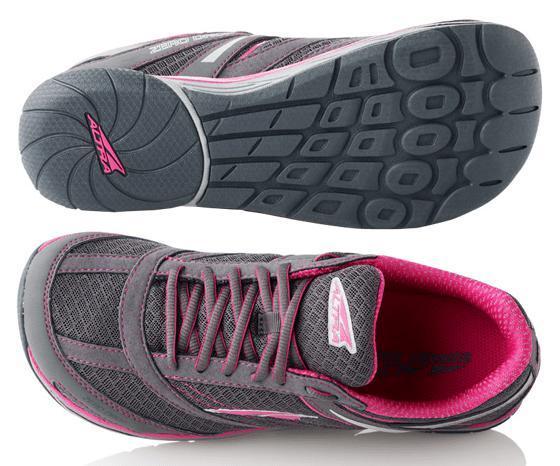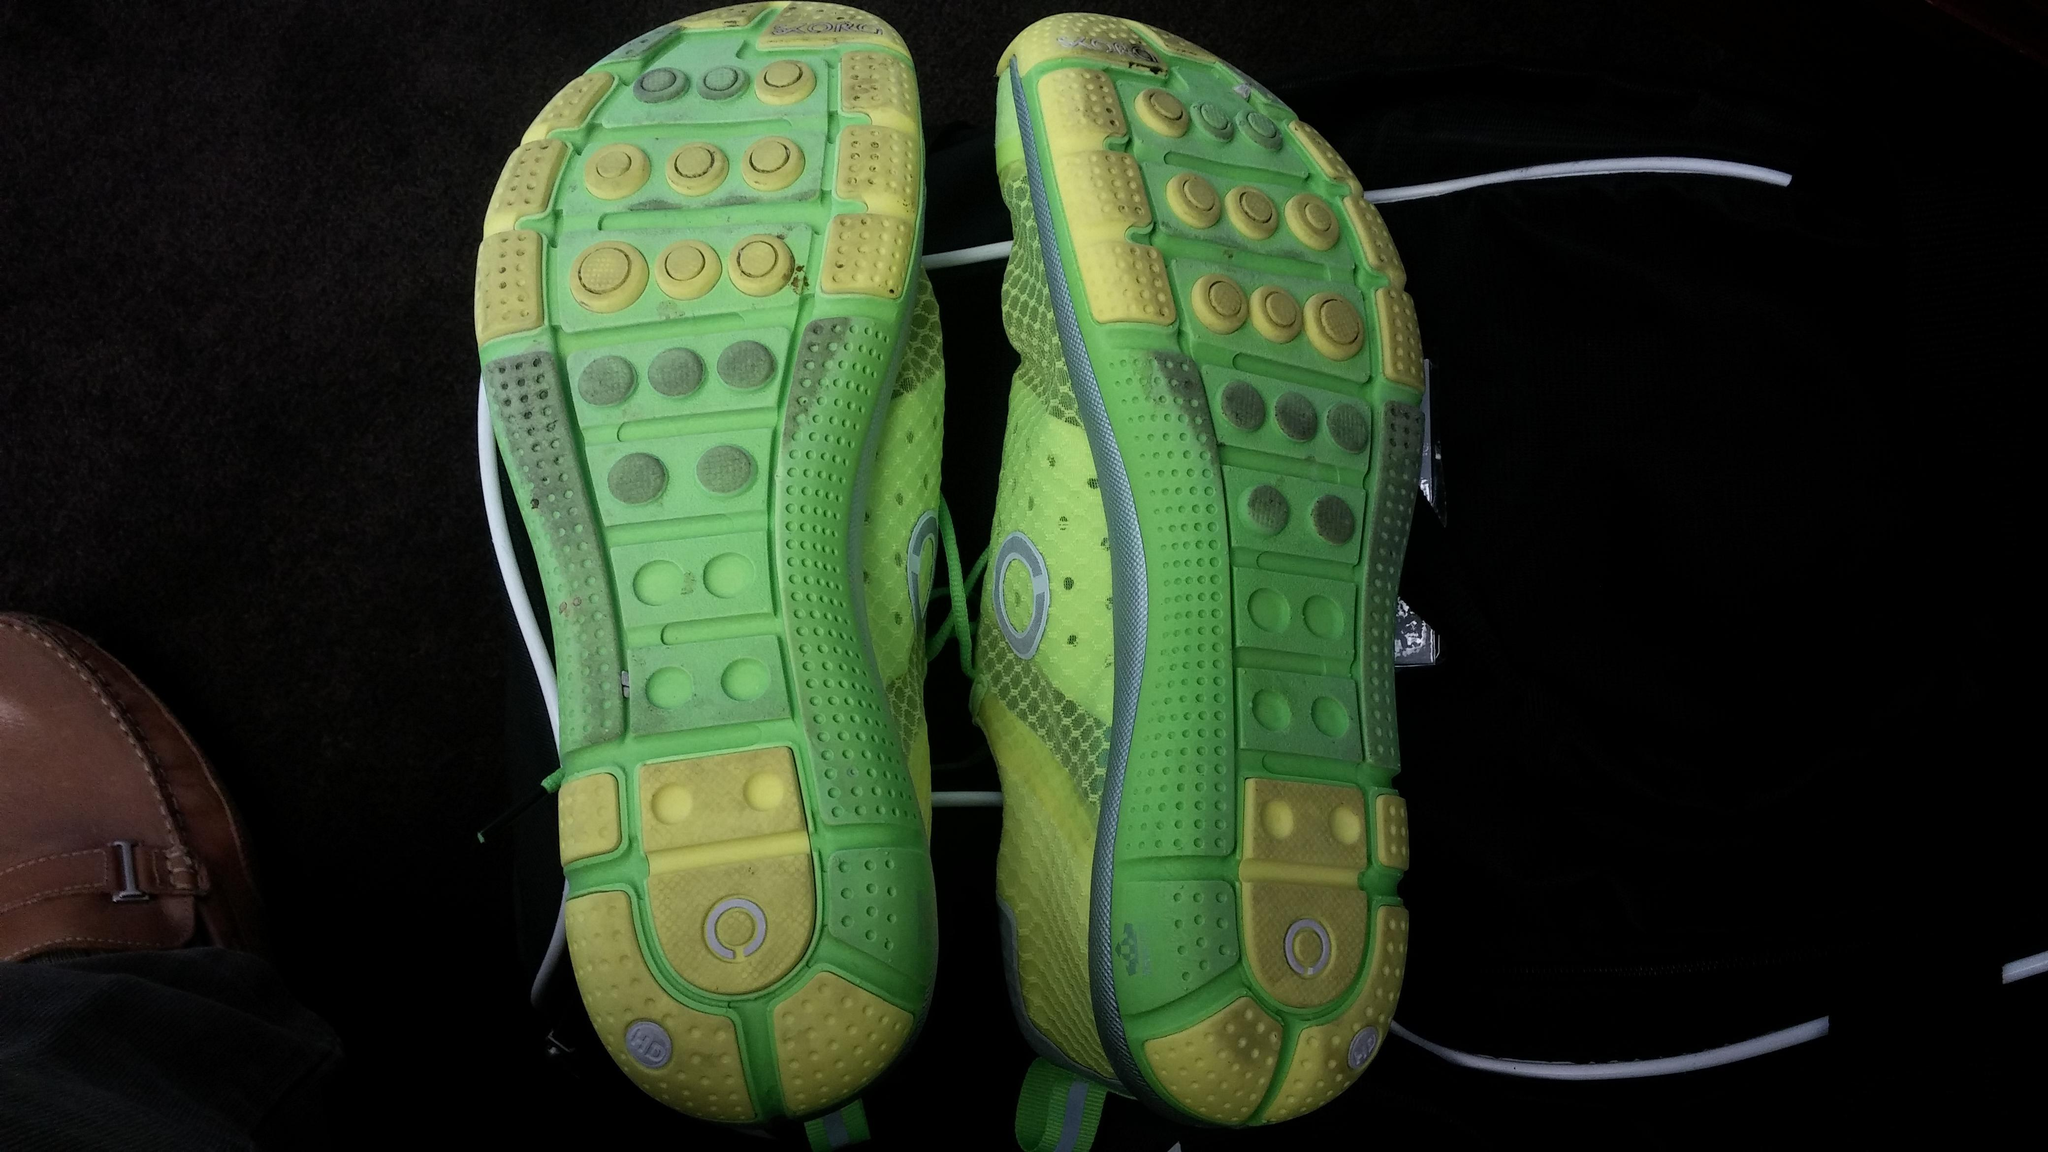The first image is the image on the left, the second image is the image on the right. Given the left and right images, does the statement "One image is a top-view of human feet wearing matching sneakers with white laces." hold true? Answer yes or no. No. The first image is the image on the left, the second image is the image on the right. Considering the images on both sides, is "At least one image shows a pair of running shoes that are being worn on a person's feet" valid? Answer yes or no. No. 